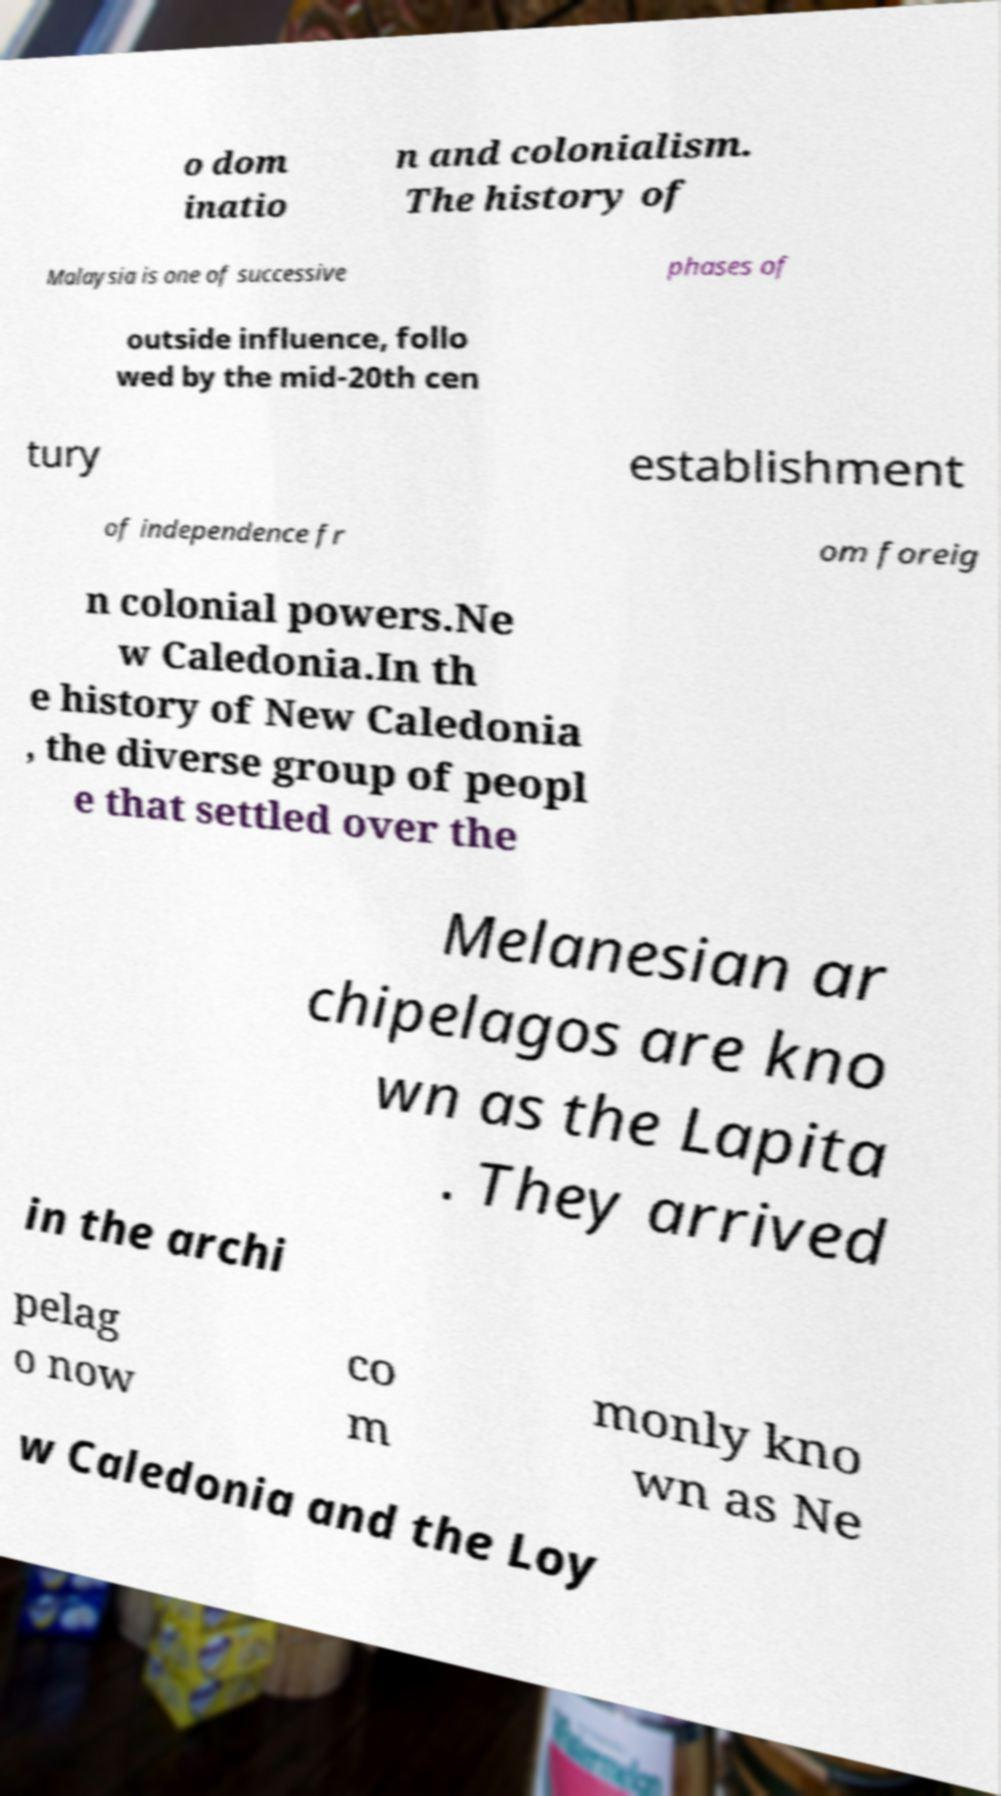Could you extract and type out the text from this image? o dom inatio n and colonialism. The history of Malaysia is one of successive phases of outside influence, follo wed by the mid-20th cen tury establishment of independence fr om foreig n colonial powers.Ne w Caledonia.In th e history of New Caledonia , the diverse group of peopl e that settled over the Melanesian ar chipelagos are kno wn as the Lapita . They arrived in the archi pelag o now co m monly kno wn as Ne w Caledonia and the Loy 